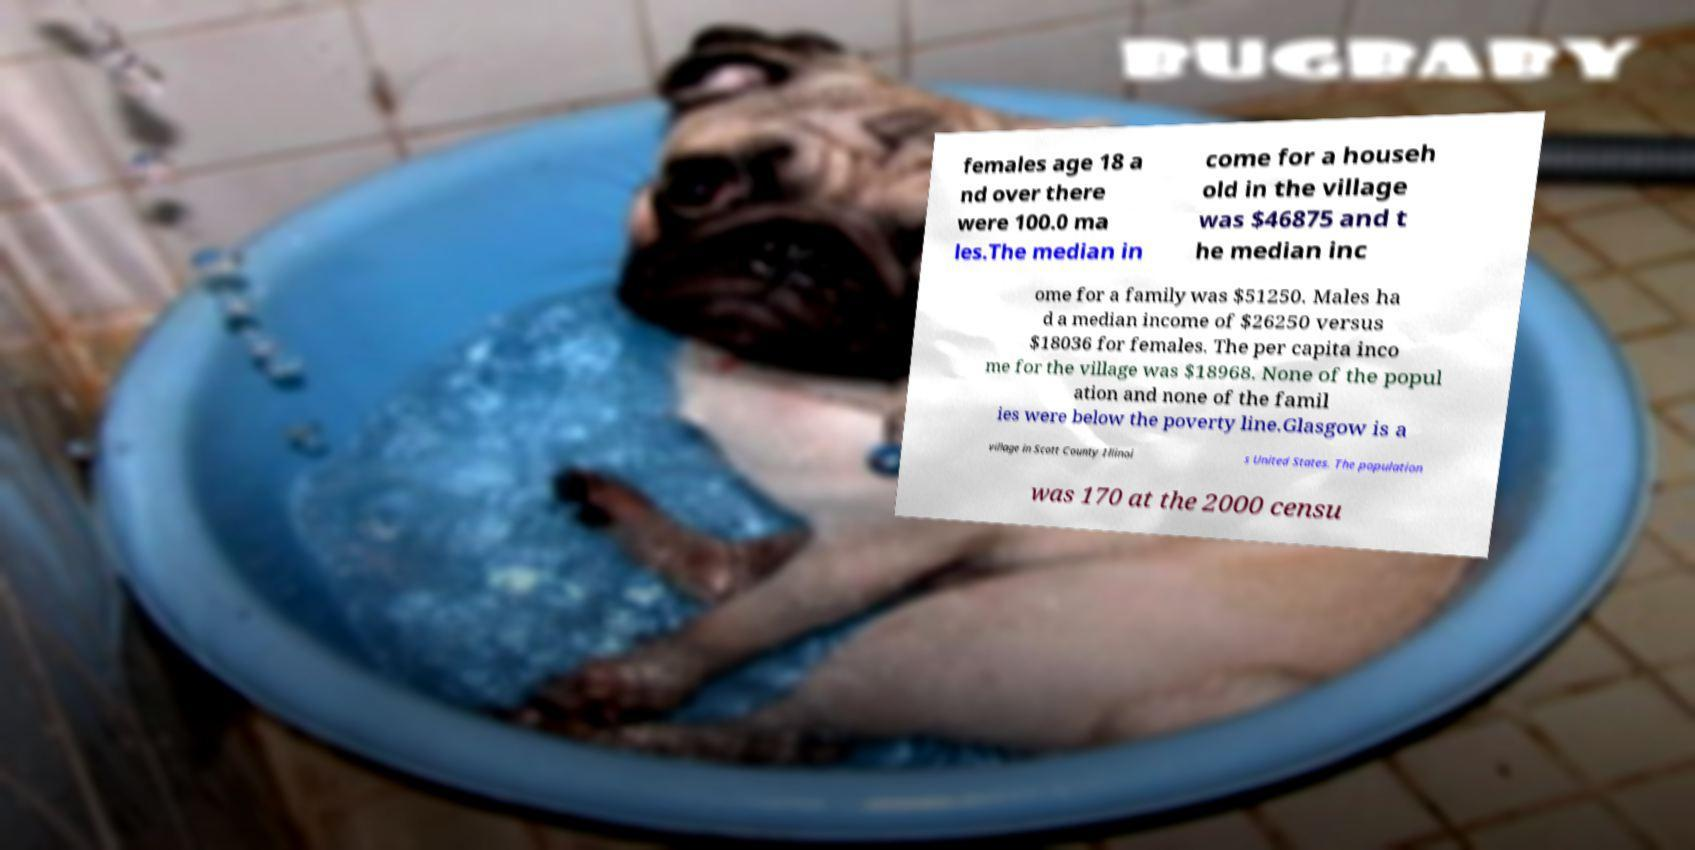For documentation purposes, I need the text within this image transcribed. Could you provide that? females age 18 a nd over there were 100.0 ma les.The median in come for a househ old in the village was $46875 and t he median inc ome for a family was $51250. Males ha d a median income of $26250 versus $18036 for females. The per capita inco me for the village was $18968. None of the popul ation and none of the famil ies were below the poverty line.Glasgow is a village in Scott County Illinoi s United States. The population was 170 at the 2000 censu 